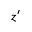<formula> <loc_0><loc_0><loc_500><loc_500>z ^ { \prime }</formula> 